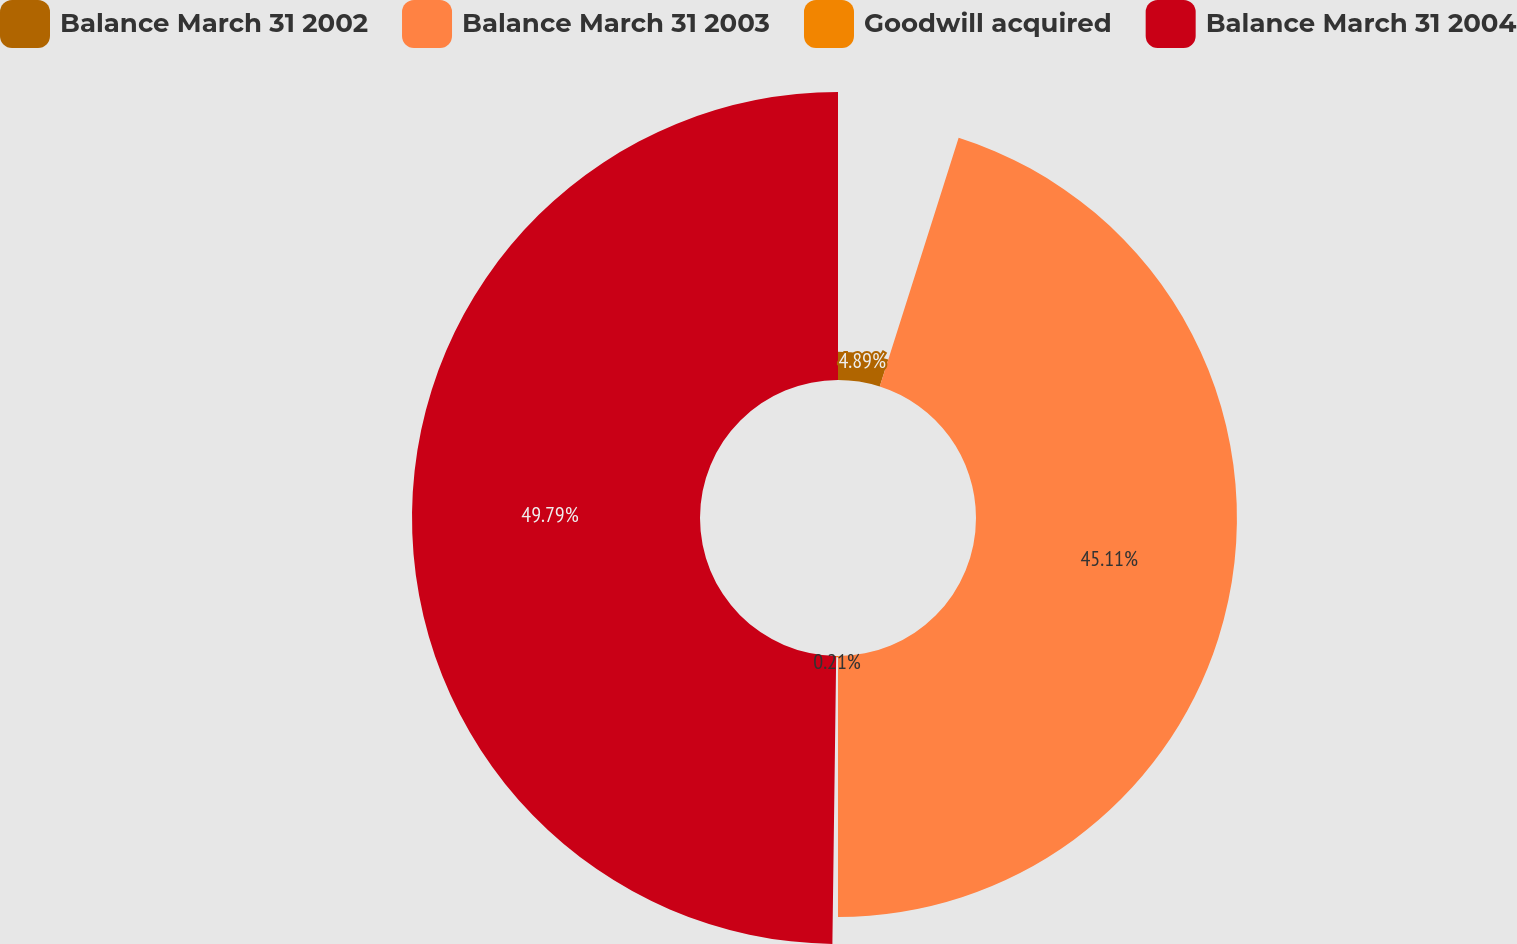Convert chart. <chart><loc_0><loc_0><loc_500><loc_500><pie_chart><fcel>Balance March 31 2002<fcel>Balance March 31 2003<fcel>Goodwill acquired<fcel>Balance March 31 2004<nl><fcel>4.89%<fcel>45.11%<fcel>0.21%<fcel>49.79%<nl></chart> 